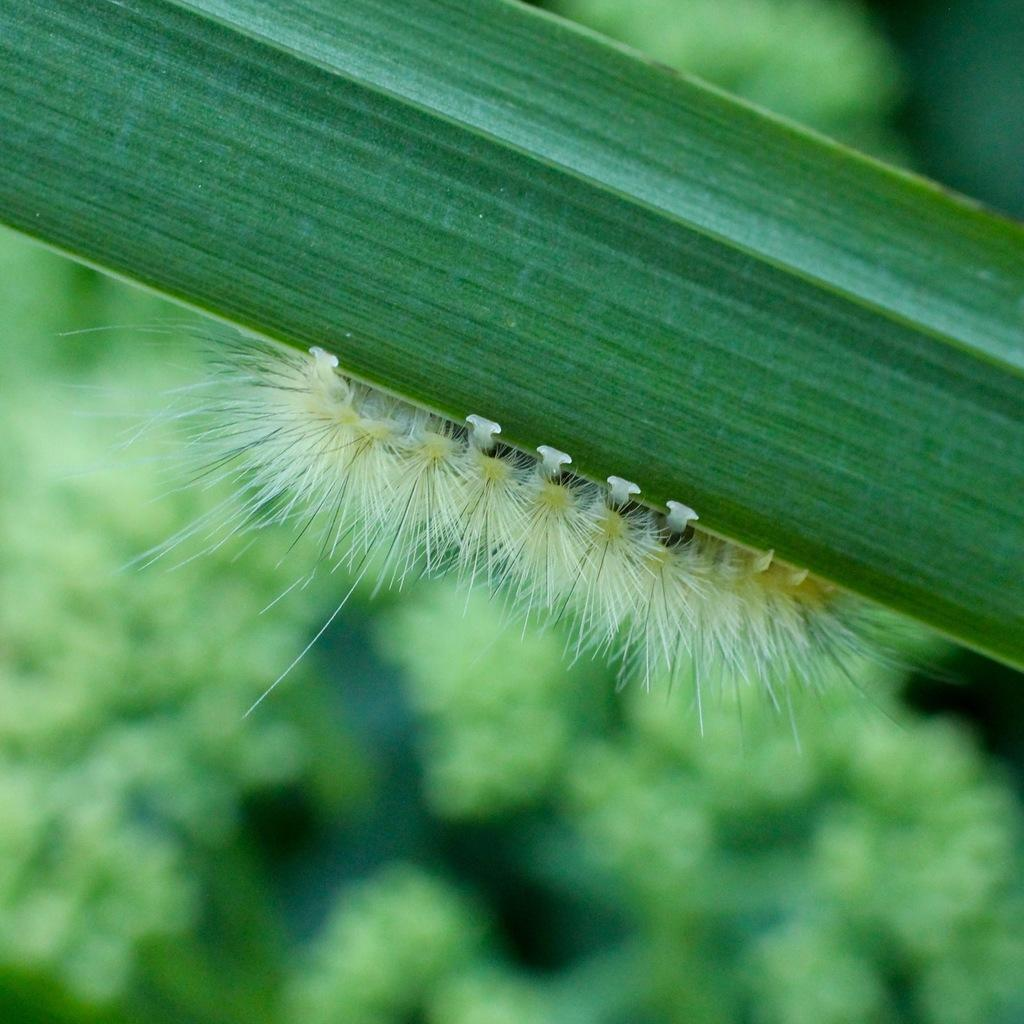What is the main subject of the image? There is a caterpillar on a leaf in the image. What can be seen in the background of the image? There are trees visible in the background of the image. What type of porter is carrying the caterpillar in the image? There is no porter present in the image, and the caterpillar is not being carried by anyone. Can you describe the face of the caterpillar in the image? Caterpillars do not have faces like humans or animals with facial features; they have a segmented body with small legs and antennae. 